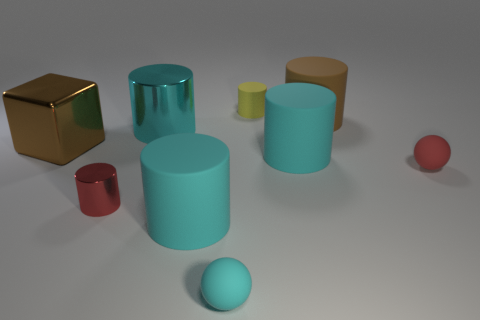Is there any other thing that has the same shape as the big brown metallic object?
Make the answer very short. No. Are there any cyan rubber objects that have the same shape as the red metal object?
Ensure brevity in your answer.  Yes. How many other things are the same color as the small shiny cylinder?
Keep it short and to the point. 1. What is the color of the tiny thing that is on the left side of the small matte thing that is in front of the tiny cylinder that is in front of the brown shiny object?
Provide a short and direct response. Red. Are there the same number of cubes to the left of the tiny rubber cylinder and cylinders?
Give a very brief answer. No. Does the block that is on the left side of the red matte object have the same size as the big metal cylinder?
Your answer should be compact. Yes. What number of small yellow rubber objects are there?
Your answer should be compact. 1. How many tiny matte objects are left of the large brown cylinder and in front of the large metallic cylinder?
Ensure brevity in your answer.  1. Is there a red sphere that has the same material as the brown cube?
Your response must be concise. No. What is the material of the red thing left of the rubber sphere behind the tiny cyan rubber sphere?
Keep it short and to the point. Metal. 